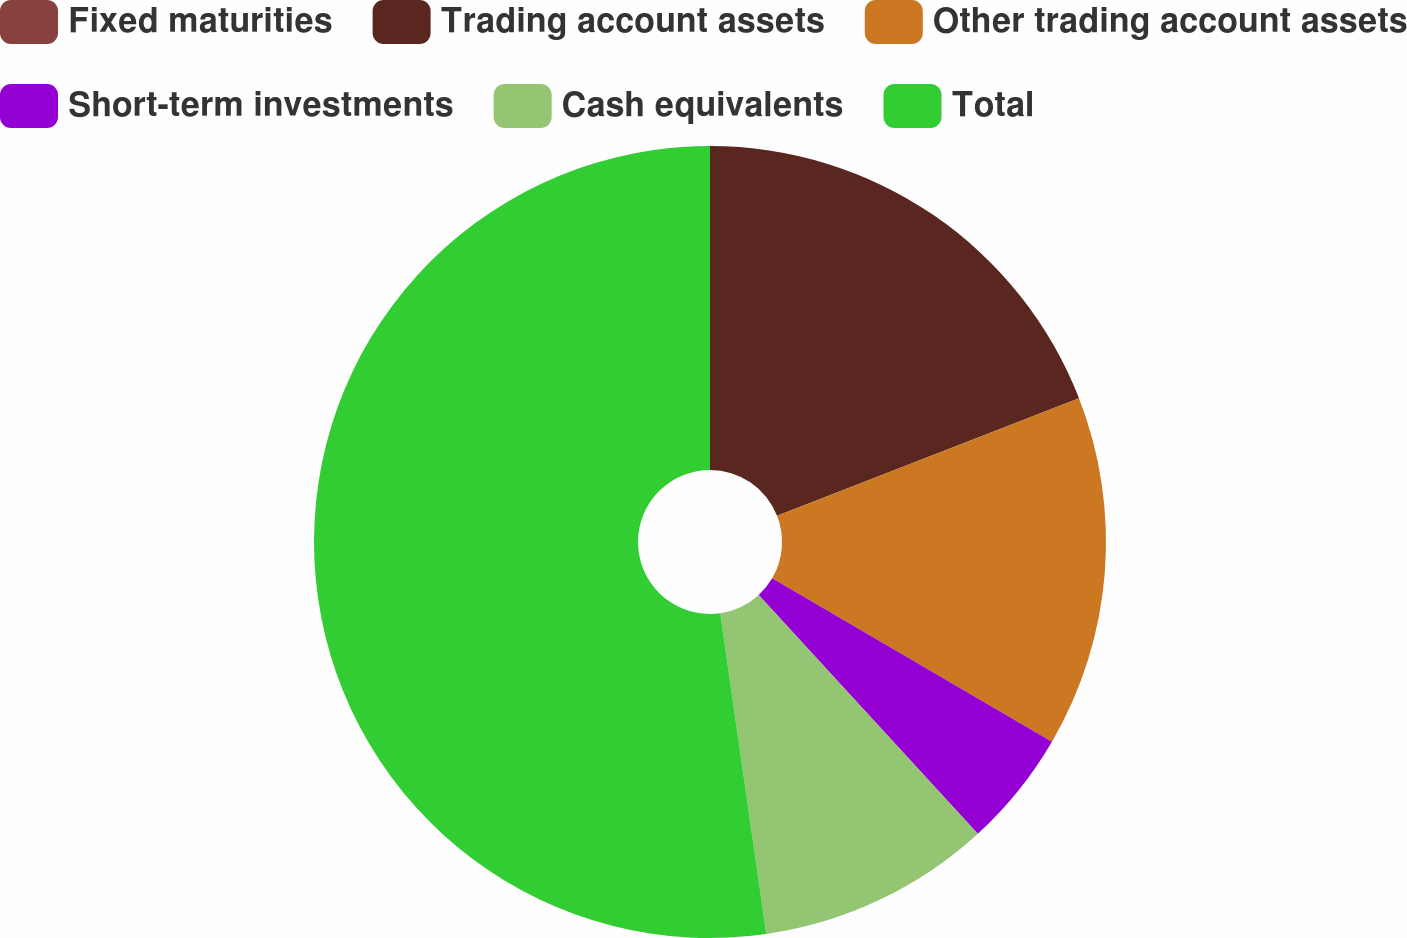Convert chart. <chart><loc_0><loc_0><loc_500><loc_500><pie_chart><fcel>Fixed maturities<fcel>Trading account assets<fcel>Other trading account assets<fcel>Short-term investments<fcel>Cash equivalents<fcel>Total<nl><fcel>0.0%<fcel>19.09%<fcel>14.32%<fcel>4.77%<fcel>9.55%<fcel>52.27%<nl></chart> 